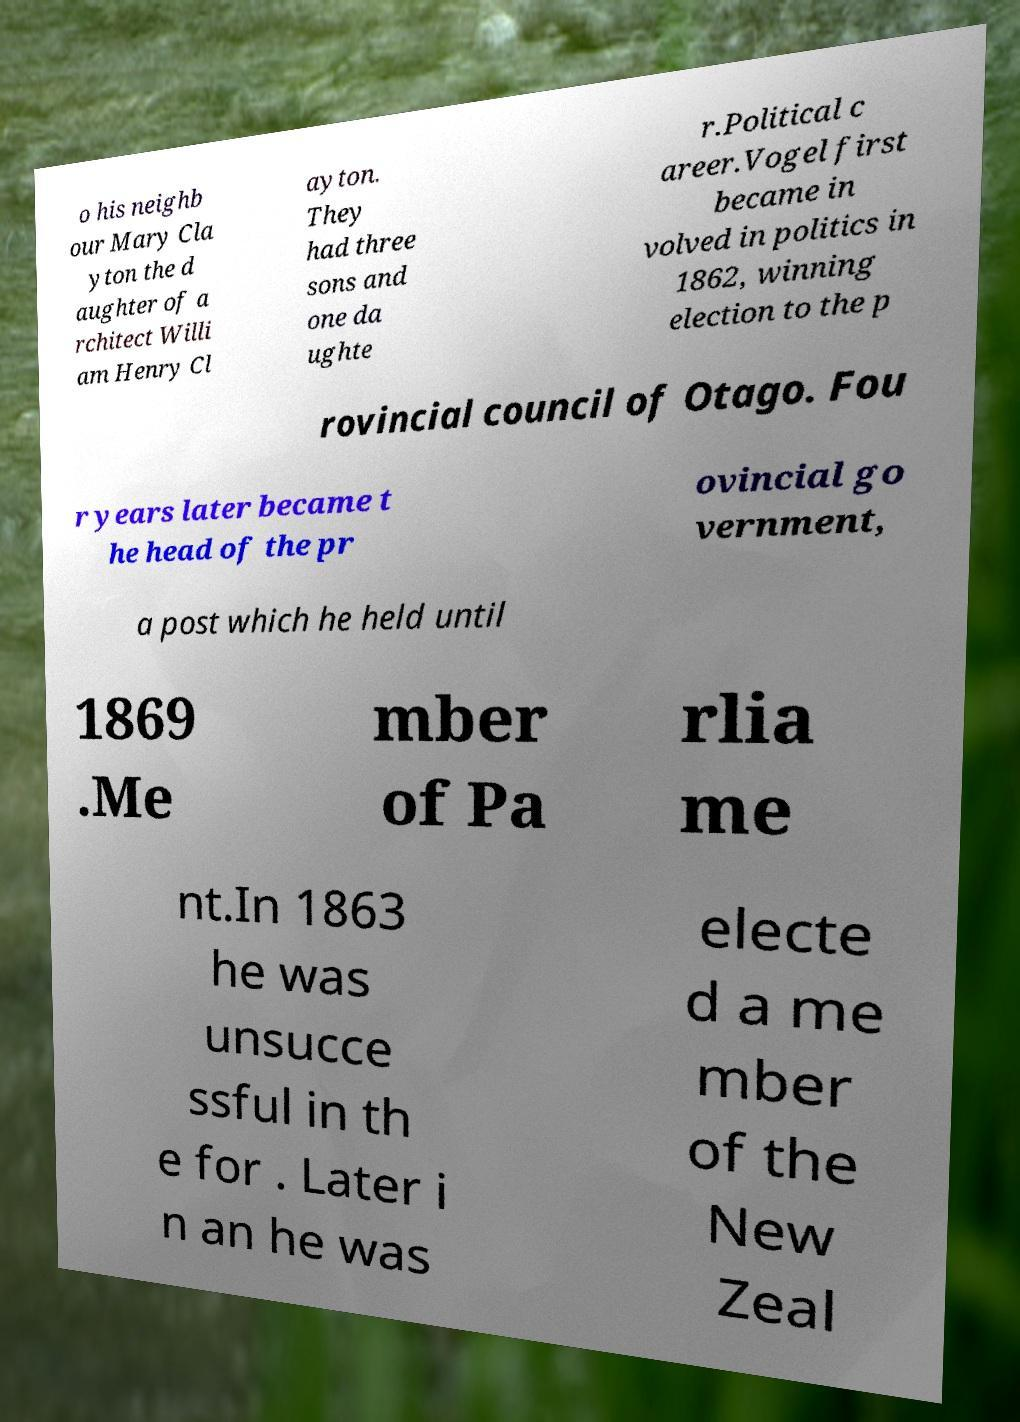For documentation purposes, I need the text within this image transcribed. Could you provide that? o his neighb our Mary Cla yton the d aughter of a rchitect Willi am Henry Cl ayton. They had three sons and one da ughte r.Political c areer.Vogel first became in volved in politics in 1862, winning election to the p rovincial council of Otago. Fou r years later became t he head of the pr ovincial go vernment, a post which he held until 1869 .Me mber of Pa rlia me nt.In 1863 he was unsucce ssful in th e for . Later i n an he was electe d a me mber of the New Zeal 